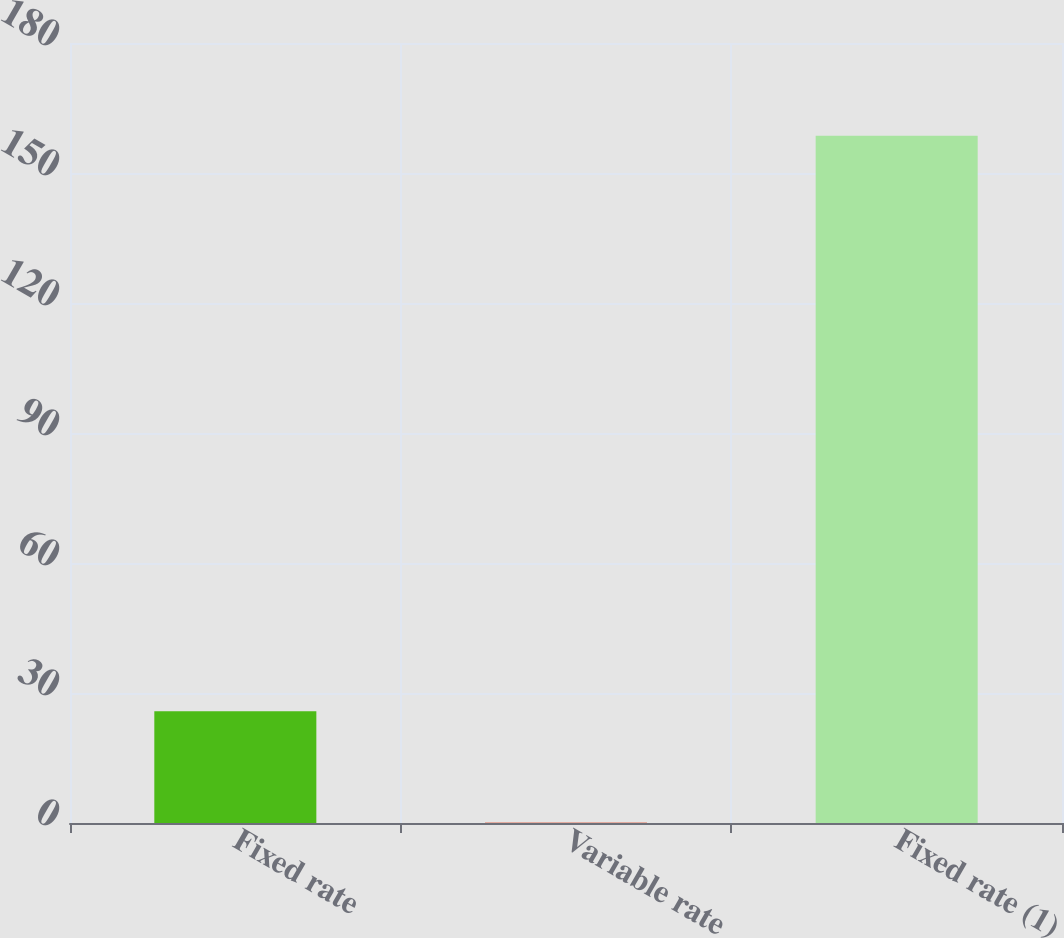Convert chart to OTSL. <chart><loc_0><loc_0><loc_500><loc_500><bar_chart><fcel>Fixed rate<fcel>Variable rate<fcel>Fixed rate (1)<nl><fcel>25.8<fcel>0.1<fcel>158.6<nl></chart> 